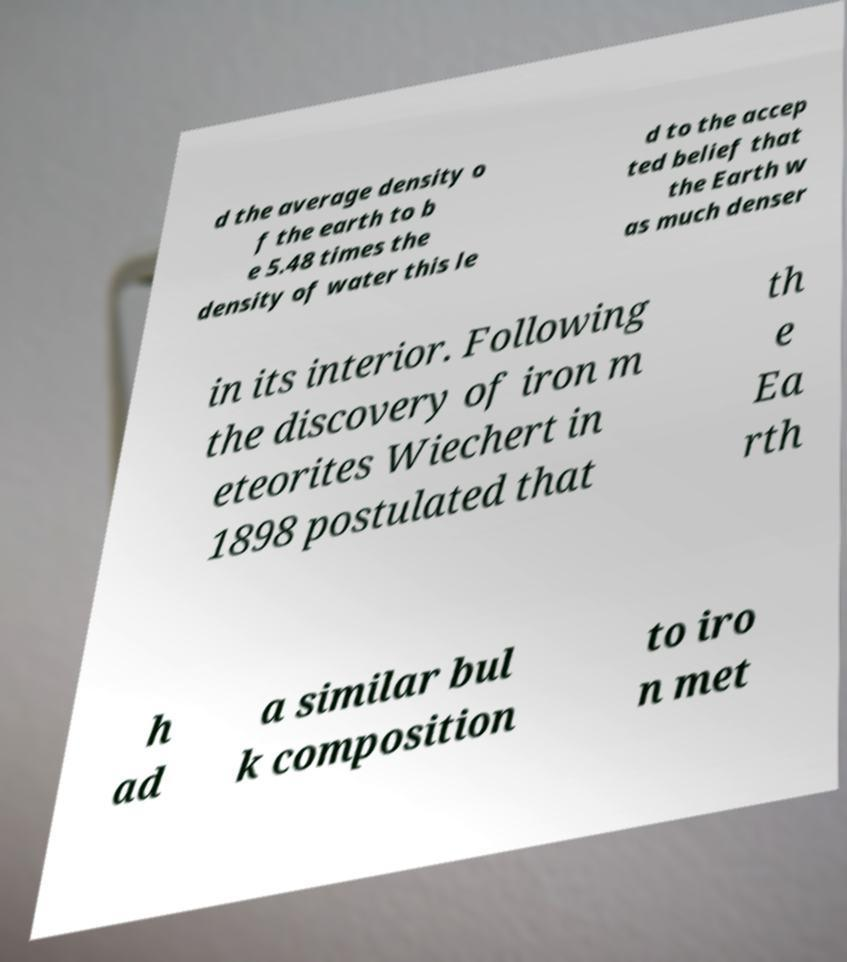Can you read and provide the text displayed in the image?This photo seems to have some interesting text. Can you extract and type it out for me? d the average density o f the earth to b e 5.48 times the density of water this le d to the accep ted belief that the Earth w as much denser in its interior. Following the discovery of iron m eteorites Wiechert in 1898 postulated that th e Ea rth h ad a similar bul k composition to iro n met 